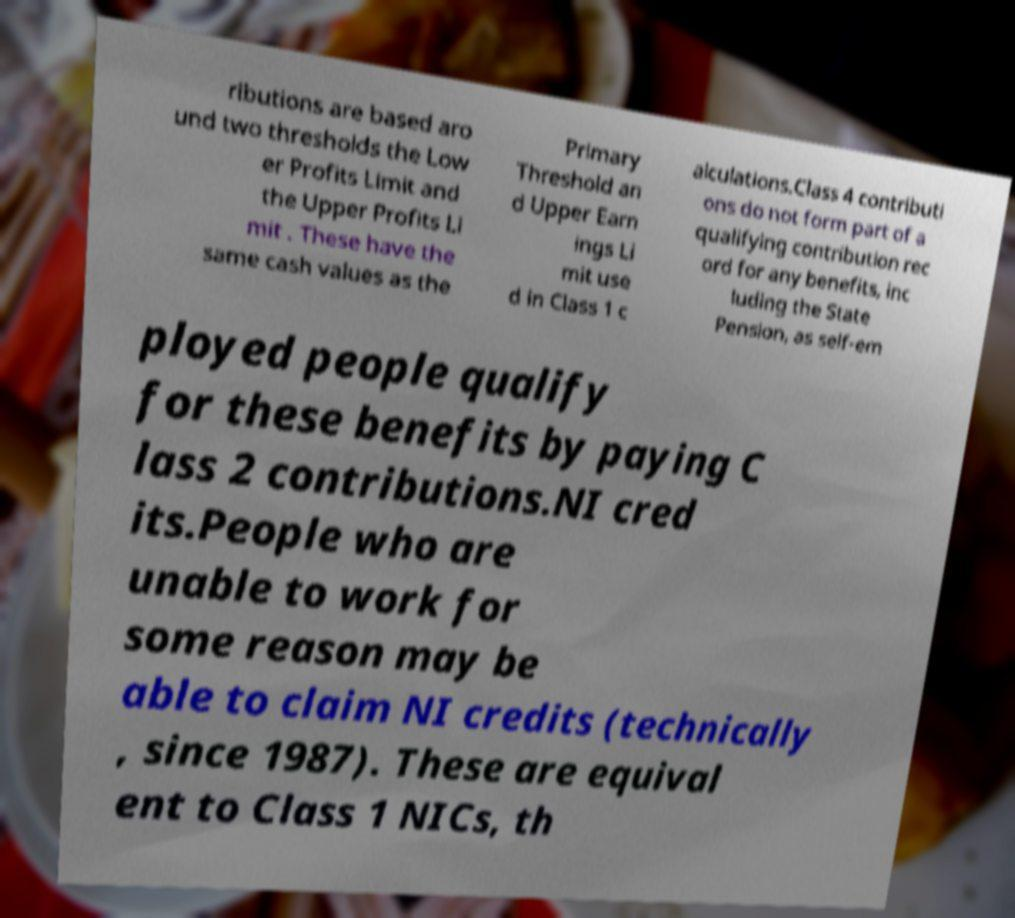Can you read and provide the text displayed in the image?This photo seems to have some interesting text. Can you extract and type it out for me? ributions are based aro und two thresholds the Low er Profits Limit and the Upper Profits Li mit . These have the same cash values as the Primary Threshold an d Upper Earn ings Li mit use d in Class 1 c alculations.Class 4 contributi ons do not form part of a qualifying contribution rec ord for any benefits, inc luding the State Pension, as self-em ployed people qualify for these benefits by paying C lass 2 contributions.NI cred its.People who are unable to work for some reason may be able to claim NI credits (technically , since 1987). These are equival ent to Class 1 NICs, th 